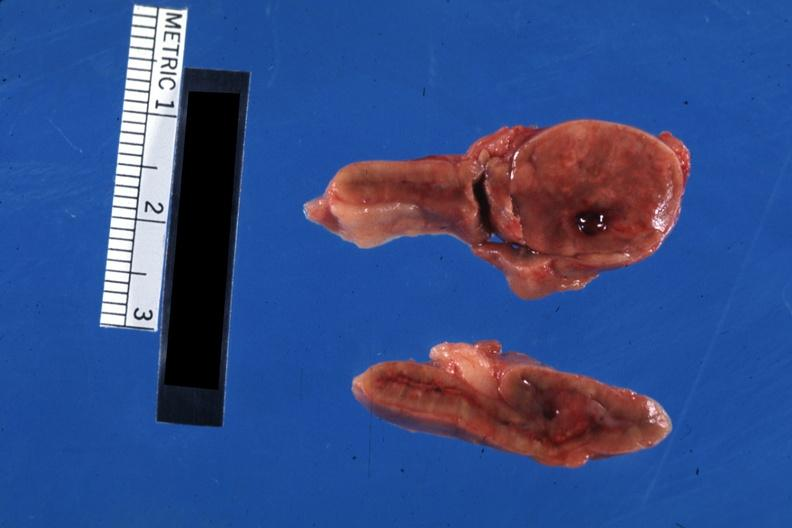does lymphangiomatosis show nicely shown single nodule close-up?
Answer the question using a single word or phrase. No 